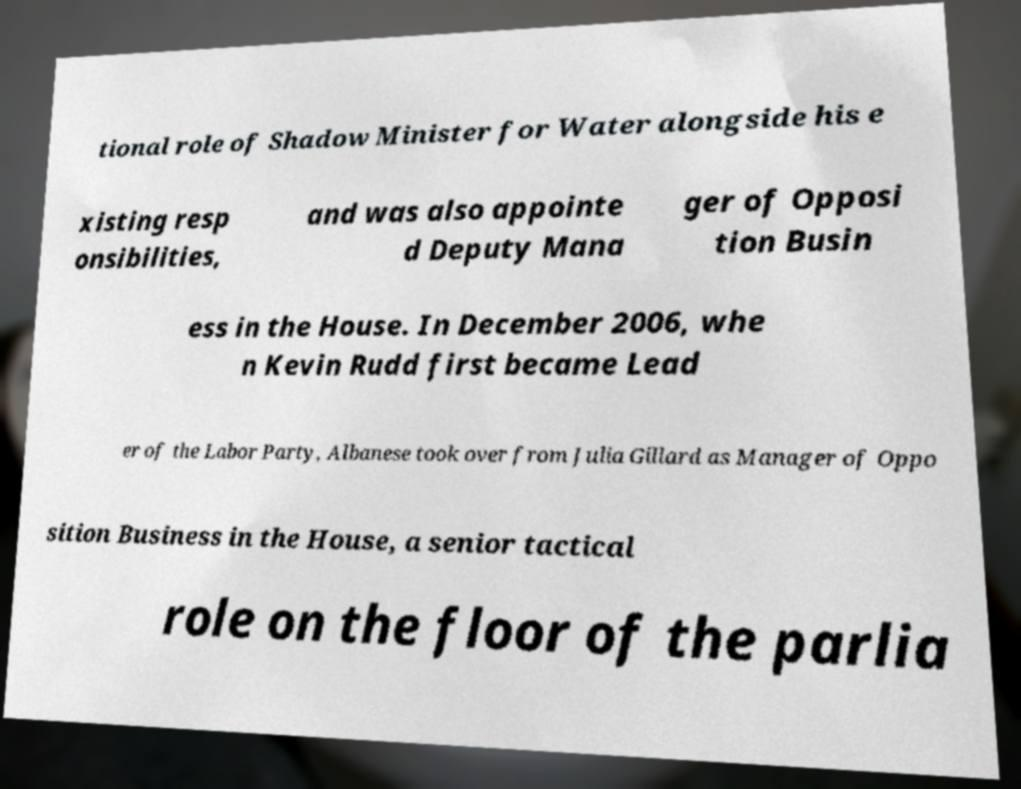Can you accurately transcribe the text from the provided image for me? tional role of Shadow Minister for Water alongside his e xisting resp onsibilities, and was also appointe d Deputy Mana ger of Opposi tion Busin ess in the House. In December 2006, whe n Kevin Rudd first became Lead er of the Labor Party, Albanese took over from Julia Gillard as Manager of Oppo sition Business in the House, a senior tactical role on the floor of the parlia 